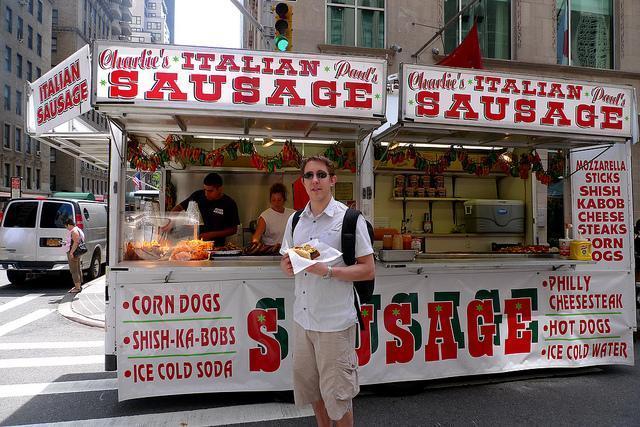How many times does the word "dogs" appear in the image?
Give a very brief answer. 3. How many people are visible?
Give a very brief answer. 2. How many windows below the clock face?
Give a very brief answer. 0. 